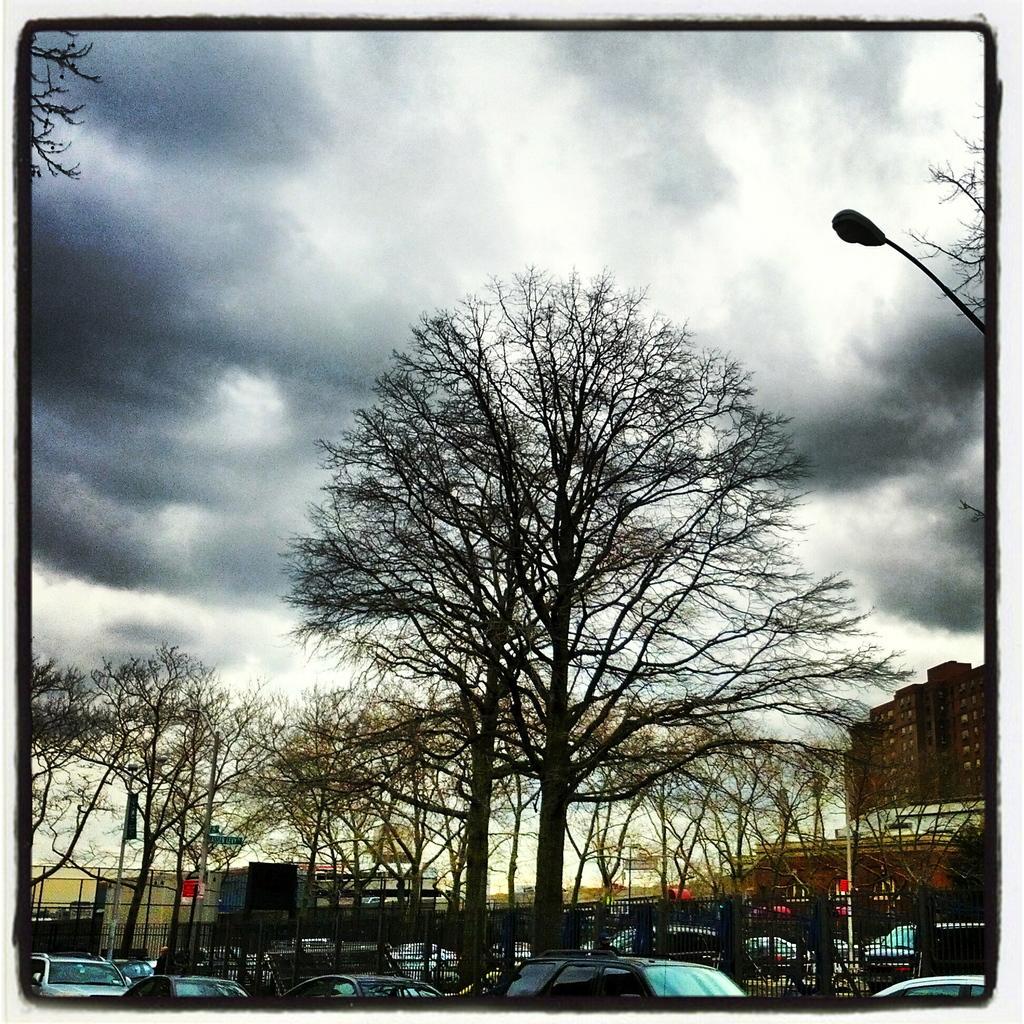Can you describe this image briefly? This is an edited image with the borders. In the foreground we can see the group of vehicles and we can see the fence, trees, poles. In the center we can see the buildings. In the background we can see the sky which is full of clouds. On the right corner we can see the street light. 